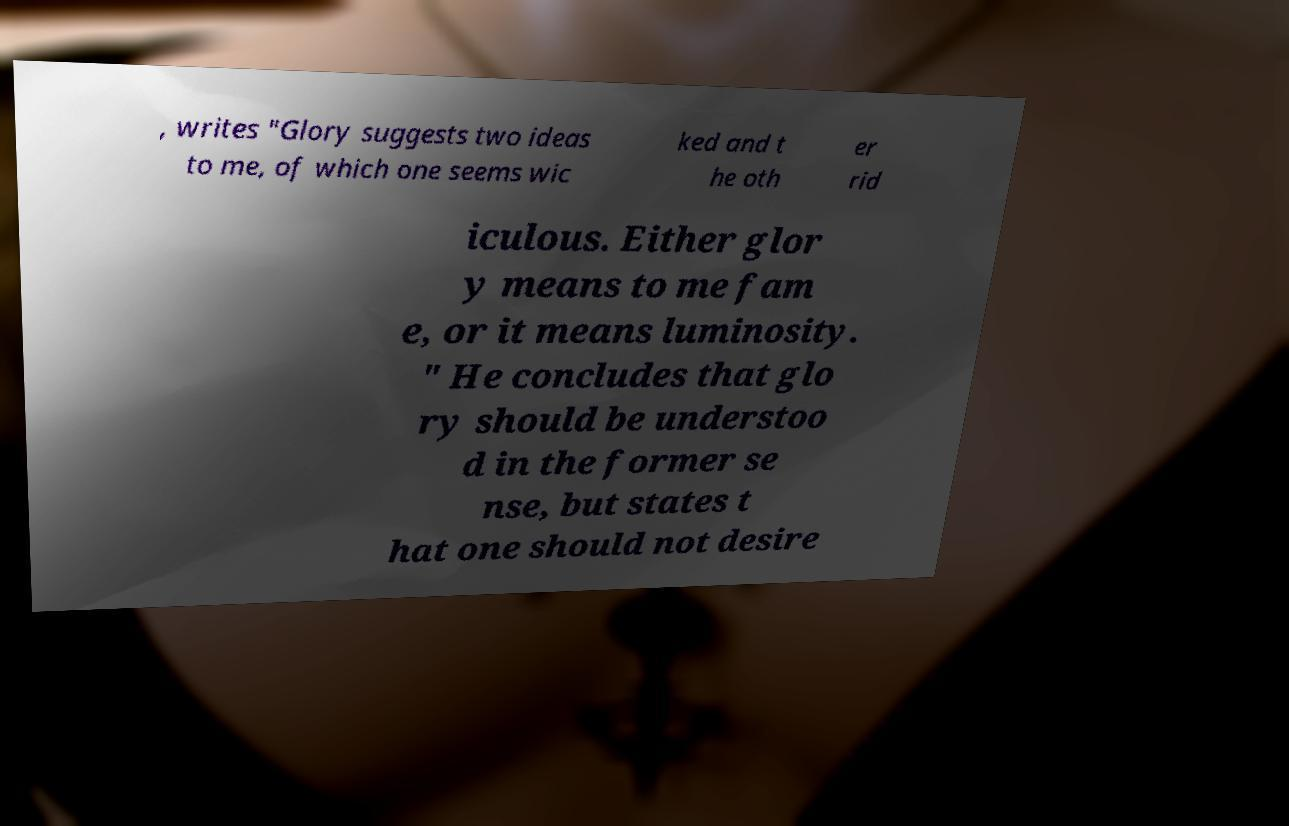I need the written content from this picture converted into text. Can you do that? , writes "Glory suggests two ideas to me, of which one seems wic ked and t he oth er rid iculous. Either glor y means to me fam e, or it means luminosity. " He concludes that glo ry should be understoo d in the former se nse, but states t hat one should not desire 